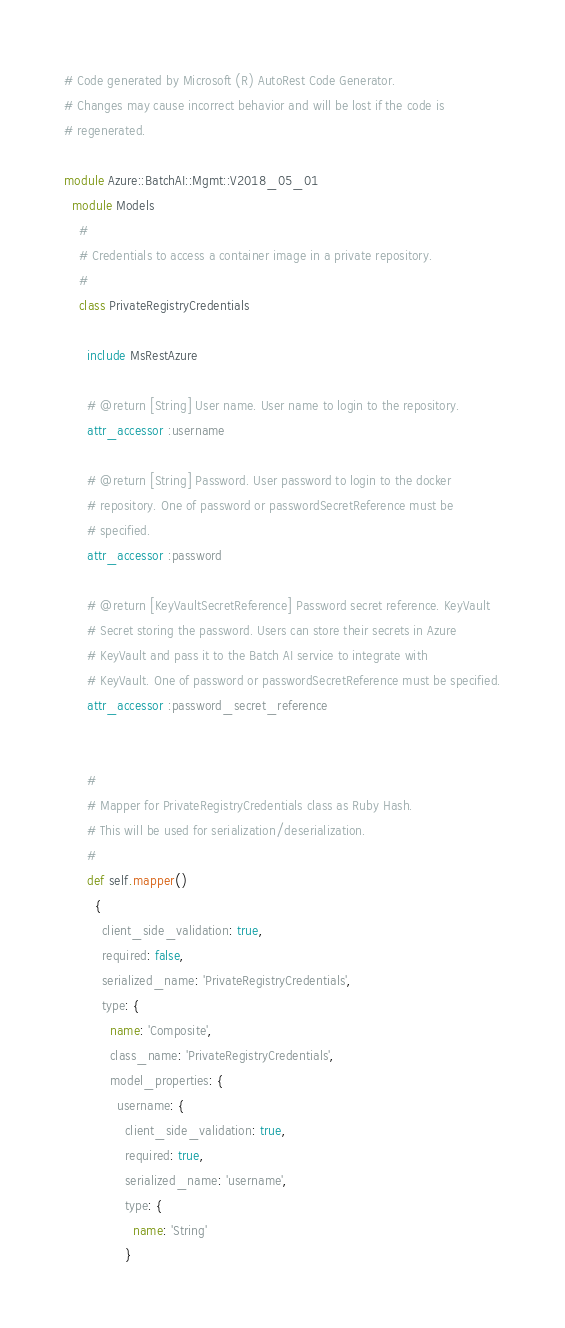<code> <loc_0><loc_0><loc_500><loc_500><_Ruby_># Code generated by Microsoft (R) AutoRest Code Generator.
# Changes may cause incorrect behavior and will be lost if the code is
# regenerated.

module Azure::BatchAI::Mgmt::V2018_05_01
  module Models
    #
    # Credentials to access a container image in a private repository.
    #
    class PrivateRegistryCredentials

      include MsRestAzure

      # @return [String] User name. User name to login to the repository.
      attr_accessor :username

      # @return [String] Password. User password to login to the docker
      # repository. One of password or passwordSecretReference must be
      # specified.
      attr_accessor :password

      # @return [KeyVaultSecretReference] Password secret reference. KeyVault
      # Secret storing the password. Users can store their secrets in Azure
      # KeyVault and pass it to the Batch AI service to integrate with
      # KeyVault. One of password or passwordSecretReference must be specified.
      attr_accessor :password_secret_reference


      #
      # Mapper for PrivateRegistryCredentials class as Ruby Hash.
      # This will be used for serialization/deserialization.
      #
      def self.mapper()
        {
          client_side_validation: true,
          required: false,
          serialized_name: 'PrivateRegistryCredentials',
          type: {
            name: 'Composite',
            class_name: 'PrivateRegistryCredentials',
            model_properties: {
              username: {
                client_side_validation: true,
                required: true,
                serialized_name: 'username',
                type: {
                  name: 'String'
                }</code> 